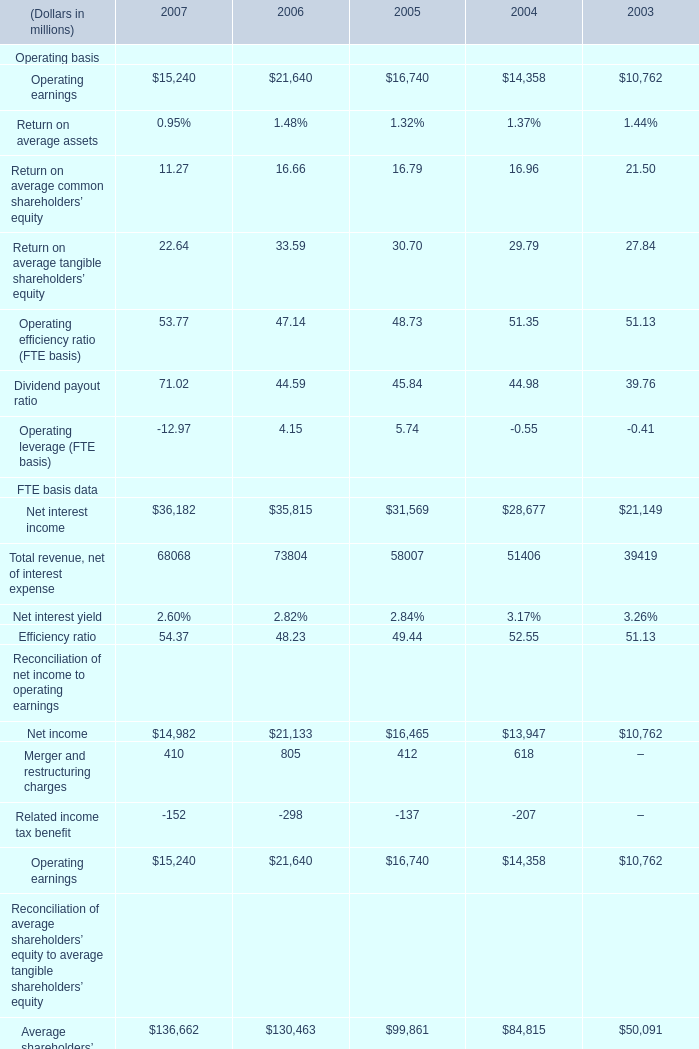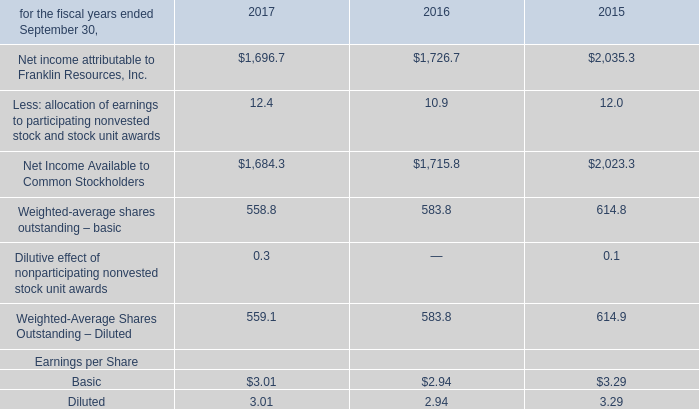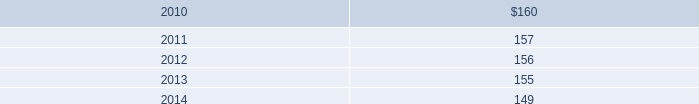In what year is net income greater than 20000? 
Answer: 2006. 